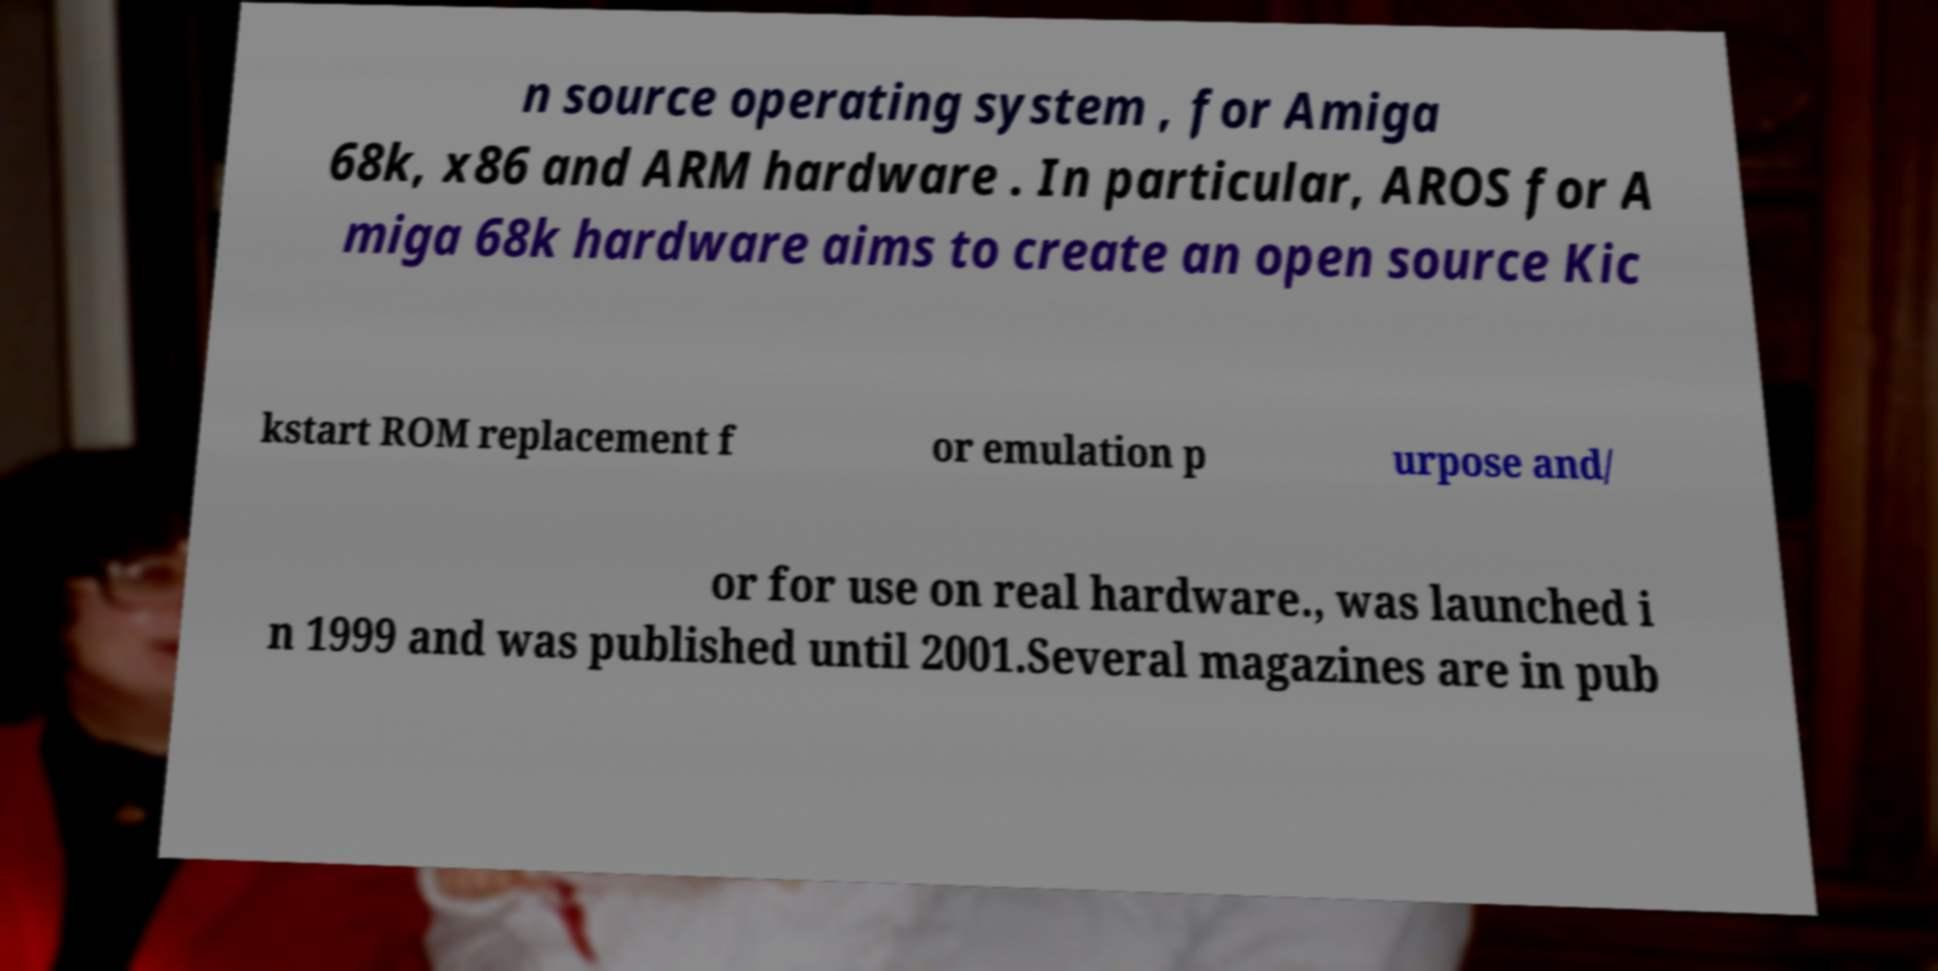There's text embedded in this image that I need extracted. Can you transcribe it verbatim? n source operating system , for Amiga 68k, x86 and ARM hardware . In particular, AROS for A miga 68k hardware aims to create an open source Kic kstart ROM replacement f or emulation p urpose and/ or for use on real hardware., was launched i n 1999 and was published until 2001.Several magazines are in pub 